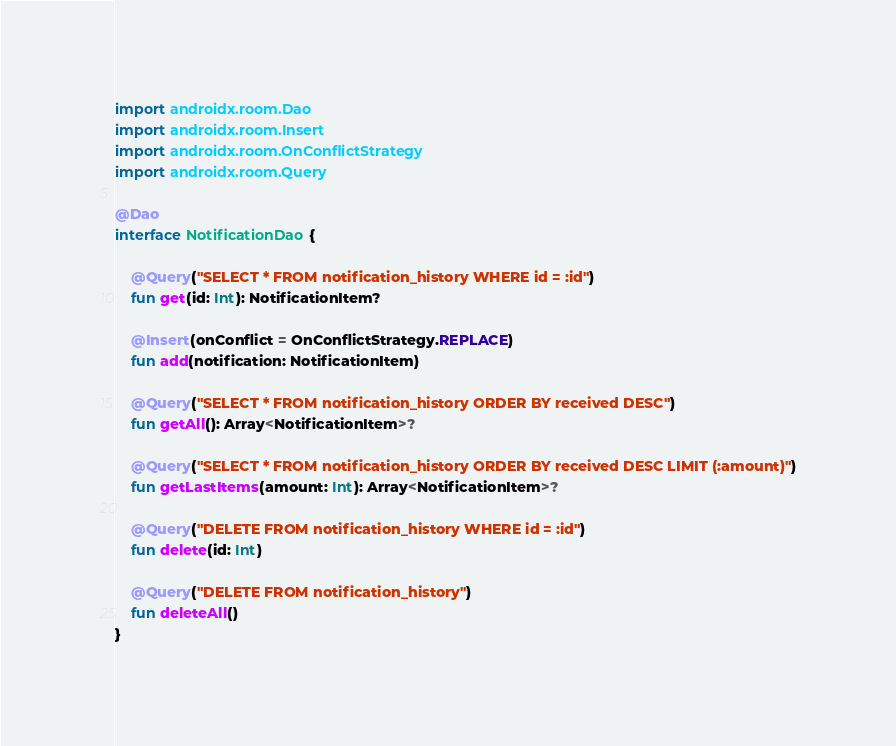Convert code to text. <code><loc_0><loc_0><loc_500><loc_500><_Kotlin_>
import androidx.room.Dao
import androidx.room.Insert
import androidx.room.OnConflictStrategy
import androidx.room.Query

@Dao
interface NotificationDao {

    @Query("SELECT * FROM notification_history WHERE id = :id")
    fun get(id: Int): NotificationItem?

    @Insert(onConflict = OnConflictStrategy.REPLACE)
    fun add(notification: NotificationItem)

    @Query("SELECT * FROM notification_history ORDER BY received DESC")
    fun getAll(): Array<NotificationItem>?

    @Query("SELECT * FROM notification_history ORDER BY received DESC LIMIT (:amount)")
    fun getLastItems(amount: Int): Array<NotificationItem>?

    @Query("DELETE FROM notification_history WHERE id = :id")
    fun delete(id: Int)

    @Query("DELETE FROM notification_history")
    fun deleteAll()
}
</code> 